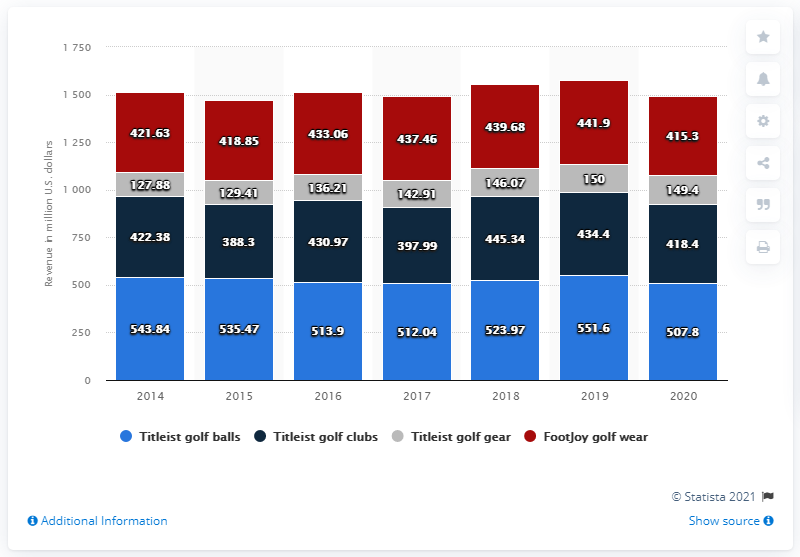Highlight a few significant elements in this photo. FootJoy's revenue in 2020 was 418.4 million dollars. 